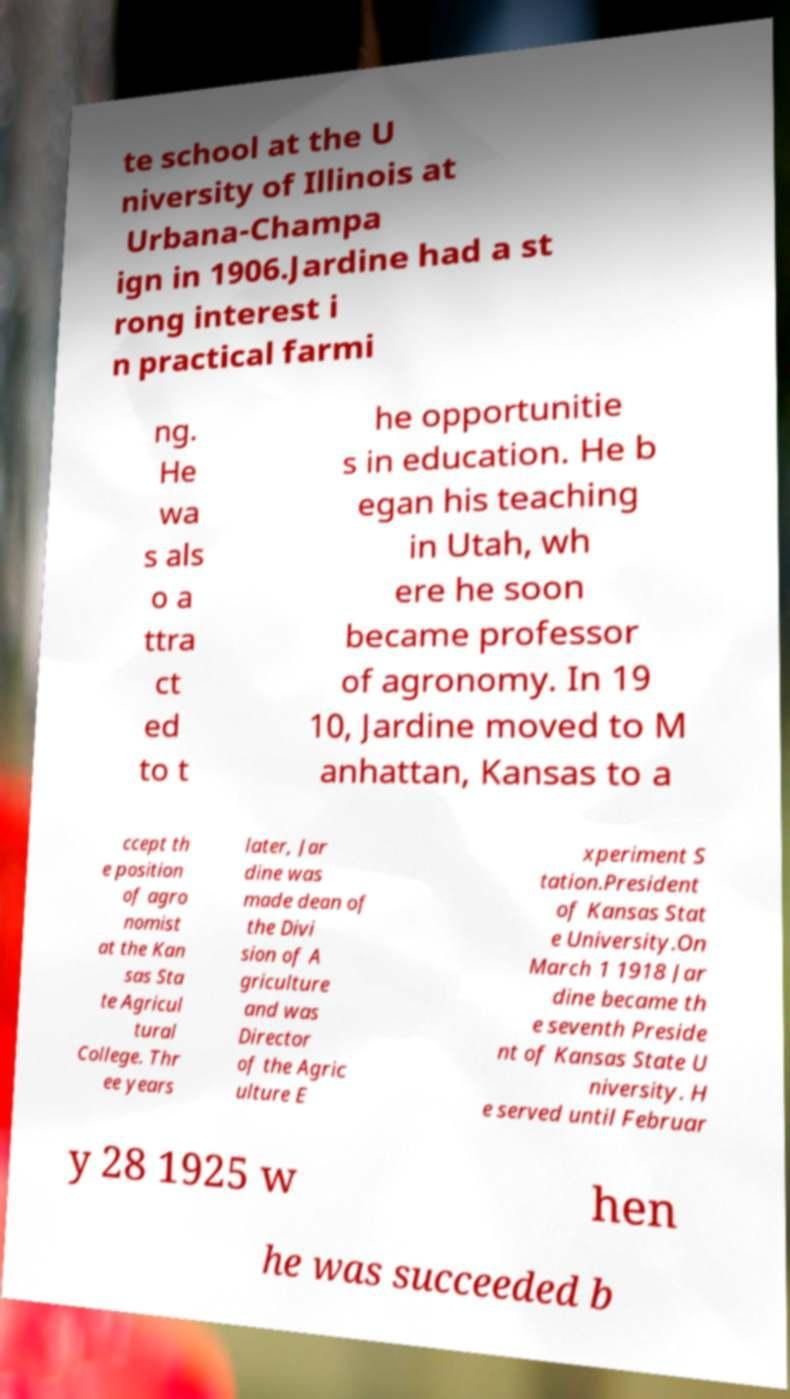Could you assist in decoding the text presented in this image and type it out clearly? te school at the U niversity of Illinois at Urbana-Champa ign in 1906.Jardine had a st rong interest i n practical farmi ng. He wa s als o a ttra ct ed to t he opportunitie s in education. He b egan his teaching in Utah, wh ere he soon became professor of agronomy. In 19 10, Jardine moved to M anhattan, Kansas to a ccept th e position of agro nomist at the Kan sas Sta te Agricul tural College. Thr ee years later, Jar dine was made dean of the Divi sion of A griculture and was Director of the Agric ulture E xperiment S tation.President of Kansas Stat e University.On March 1 1918 Jar dine became th e seventh Preside nt of Kansas State U niversity. H e served until Februar y 28 1925 w hen he was succeeded b 